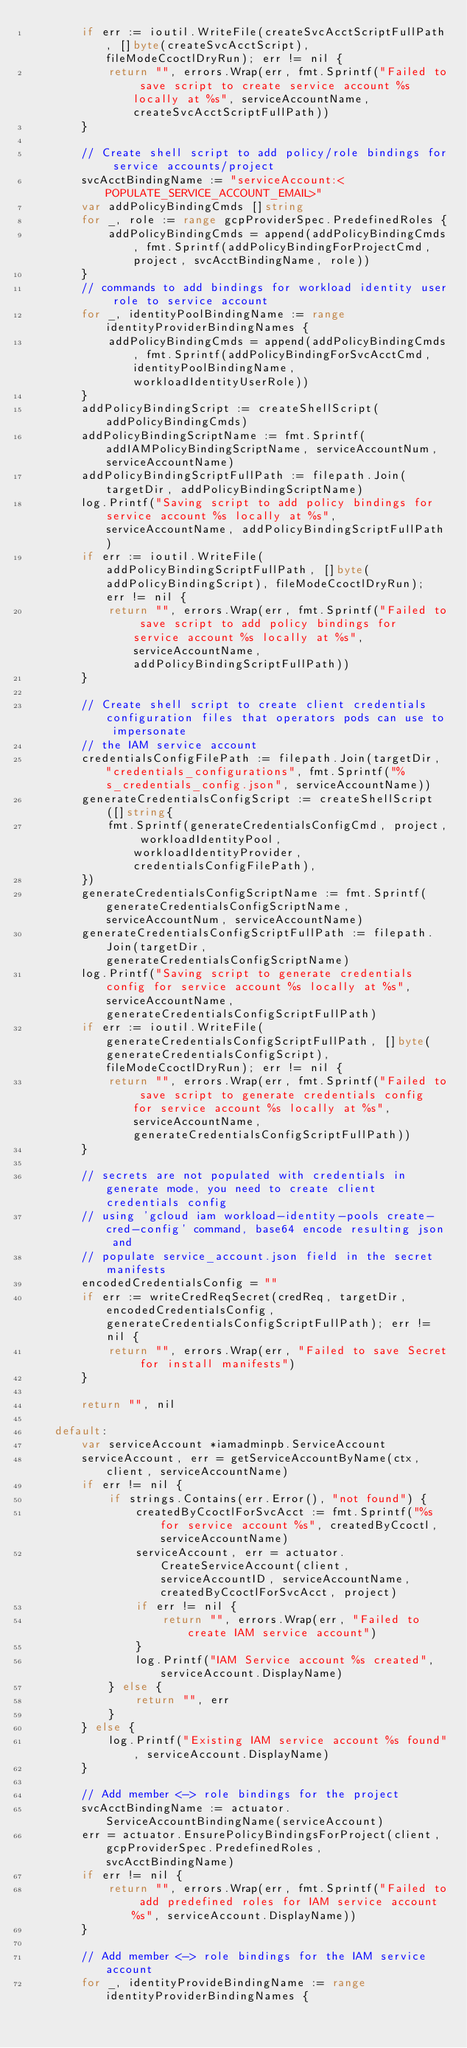Convert code to text. <code><loc_0><loc_0><loc_500><loc_500><_Go_>		if err := ioutil.WriteFile(createSvcAcctScriptFullPath, []byte(createSvcAcctScript), fileModeCcoctlDryRun); err != nil {
			return "", errors.Wrap(err, fmt.Sprintf("Failed to save script to create service account %s locally at %s", serviceAccountName, createSvcAcctScriptFullPath))
		}

		// Create shell script to add policy/role bindings for service accounts/project
		svcAcctBindingName := "serviceAccount:<POPULATE_SERVICE_ACCOUNT_EMAIL>"
		var addPolicyBindingCmds []string
		for _, role := range gcpProviderSpec.PredefinedRoles {
			addPolicyBindingCmds = append(addPolicyBindingCmds, fmt.Sprintf(addPolicyBindingForProjectCmd, project, svcAcctBindingName, role))
		}
		// commands to add bindings for workload identity user role to service account
		for _, identityPoolBindingName := range identityProviderBindingNames {
			addPolicyBindingCmds = append(addPolicyBindingCmds, fmt.Sprintf(addPolicyBindingForSvcAcctCmd, identityPoolBindingName, workloadIdentityUserRole))
		}
		addPolicyBindingScript := createShellScript(addPolicyBindingCmds)
		addPolicyBindingScriptName := fmt.Sprintf(addIAMPolicyBindingScriptName, serviceAccountNum, serviceAccountName)
		addPolicyBindingScriptFullPath := filepath.Join(targetDir, addPolicyBindingScriptName)
		log.Printf("Saving script to add policy bindings for service account %s locally at %s", serviceAccountName, addPolicyBindingScriptFullPath)
		if err := ioutil.WriteFile(addPolicyBindingScriptFullPath, []byte(addPolicyBindingScript), fileModeCcoctlDryRun); err != nil {
			return "", errors.Wrap(err, fmt.Sprintf("Failed to save script to add policy bindings for service account %s locally at %s", serviceAccountName, addPolicyBindingScriptFullPath))
		}

		// Create shell script to create client credentials configuration files that operators pods can use to impersonate
		// the IAM service account
		credentialsConfigFilePath := filepath.Join(targetDir, "credentials_configurations", fmt.Sprintf("%s_credentials_config.json", serviceAccountName))
		generateCredentialsConfigScript := createShellScript([]string{
			fmt.Sprintf(generateCredentialsConfigCmd, project, workloadIdentityPool, workloadIdentityProvider, credentialsConfigFilePath),
		})
		generateCredentialsConfigScriptName := fmt.Sprintf(generateCredentialsConfigScriptName, serviceAccountNum, serviceAccountName)
		generateCredentialsConfigScriptFullPath := filepath.Join(targetDir, generateCredentialsConfigScriptName)
		log.Printf("Saving script to generate credentials config for service account %s locally at %s", serviceAccountName, generateCredentialsConfigScriptFullPath)
		if err := ioutil.WriteFile(generateCredentialsConfigScriptFullPath, []byte(generateCredentialsConfigScript), fileModeCcoctlDryRun); err != nil {
			return "", errors.Wrap(err, fmt.Sprintf("Failed to save script to generate credentials config for service account %s locally at %s", serviceAccountName, generateCredentialsConfigScriptFullPath))
		}

		// secrets are not populated with credentials in generate mode, you need to create client credentials config
		// using 'gcloud iam workload-identity-pools create-cred-config' command, base64 encode resulting json and
		// populate service_account.json field in the secret manifests
		encodedCredentialsConfig = ""
		if err := writeCredReqSecret(credReq, targetDir, encodedCredentialsConfig, generateCredentialsConfigScriptFullPath); err != nil {
			return "", errors.Wrap(err, "Failed to save Secret for install manifests")
		}

		return "", nil

	default:
		var serviceAccount *iamadminpb.ServiceAccount
		serviceAccount, err = getServiceAccountByName(ctx, client, serviceAccountName)
		if err != nil {
			if strings.Contains(err.Error(), "not found") {
				createdByCcoctlForSvcAcct := fmt.Sprintf("%s for service account %s", createdByCcoctl, serviceAccountName)
				serviceAccount, err = actuator.CreateServiceAccount(client, serviceAccountID, serviceAccountName, createdByCcoctlForSvcAcct, project)
				if err != nil {
					return "", errors.Wrap(err, "Failed to create IAM service account")
				}
				log.Printf("IAM Service account %s created", serviceAccount.DisplayName)
			} else {
				return "", err
			}
		} else {
			log.Printf("Existing IAM service account %s found", serviceAccount.DisplayName)
		}

		// Add member <-> role bindings for the project
		svcAcctBindingName := actuator.ServiceAccountBindingName(serviceAccount)
		err = actuator.EnsurePolicyBindingsForProject(client, gcpProviderSpec.PredefinedRoles, svcAcctBindingName)
		if err != nil {
			return "", errors.Wrap(err, fmt.Sprintf("Failed to add predefined roles for IAM service account %s", serviceAccount.DisplayName))
		}

		// Add member <-> role bindings for the IAM service account
		for _, identityProvideBindingName := range identityProviderBindingNames {</code> 